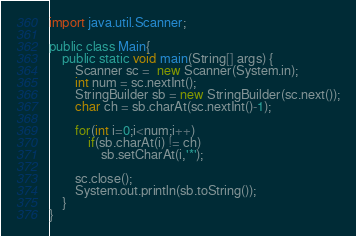Convert code to text. <code><loc_0><loc_0><loc_500><loc_500><_Java_>
import java.util.Scanner;

public class Main{
	public static void main(String[] args) {
		Scanner sc =  new Scanner(System.in);
		int num = sc.nextInt();
		StringBuilder sb = new StringBuilder(sc.next());
		char ch = sb.charAt(sc.nextInt()-1);

		for(int i=0;i<num;i++)
			if(sb.charAt(i) != ch)
				sb.setCharAt(i,'*');

		sc.close();
		System.out.println(sb.toString());
	}
}</code> 